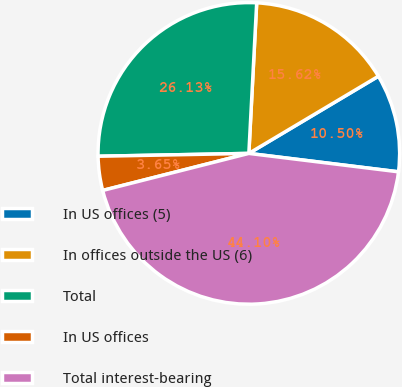Convert chart. <chart><loc_0><loc_0><loc_500><loc_500><pie_chart><fcel>In US offices (5)<fcel>In offices outside the US (6)<fcel>Total<fcel>In US offices<fcel>Total interest-bearing<nl><fcel>10.5%<fcel>15.62%<fcel>26.13%<fcel>3.65%<fcel>44.1%<nl></chart> 